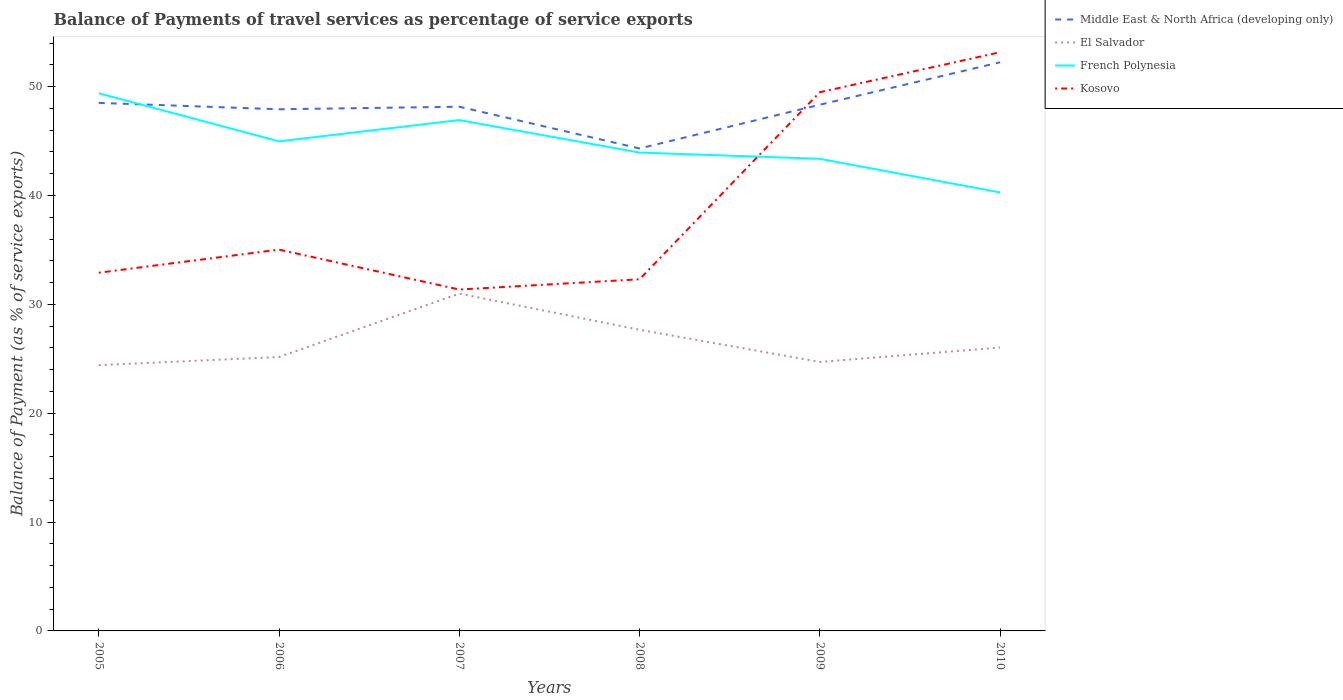Does the line corresponding to Middle East & North Africa (developing only) intersect with the line corresponding to French Polynesia?
Provide a short and direct response. Yes. Across all years, what is the maximum balance of payments of travel services in El Salvador?
Your answer should be very brief. 24.42. What is the total balance of payments of travel services in Kosovo in the graph?
Your answer should be very brief. 3.67. What is the difference between the highest and the second highest balance of payments of travel services in Middle East & North Africa (developing only)?
Ensure brevity in your answer.  7.92. What is the difference between the highest and the lowest balance of payments of travel services in French Polynesia?
Offer a very short reply. 3. How many years are there in the graph?
Give a very brief answer. 6. Where does the legend appear in the graph?
Offer a terse response. Top right. What is the title of the graph?
Make the answer very short. Balance of Payments of travel services as percentage of service exports. What is the label or title of the Y-axis?
Give a very brief answer. Balance of Payment (as % of service exports). What is the Balance of Payment (as % of service exports) of Middle East & North Africa (developing only) in 2005?
Provide a short and direct response. 48.51. What is the Balance of Payment (as % of service exports) of El Salvador in 2005?
Keep it short and to the point. 24.42. What is the Balance of Payment (as % of service exports) of French Polynesia in 2005?
Offer a terse response. 49.4. What is the Balance of Payment (as % of service exports) in Kosovo in 2005?
Provide a short and direct response. 32.91. What is the Balance of Payment (as % of service exports) in Middle East & North Africa (developing only) in 2006?
Your response must be concise. 47.93. What is the Balance of Payment (as % of service exports) of El Salvador in 2006?
Your answer should be compact. 25.17. What is the Balance of Payment (as % of service exports) of French Polynesia in 2006?
Keep it short and to the point. 44.98. What is the Balance of Payment (as % of service exports) of Kosovo in 2006?
Make the answer very short. 35.03. What is the Balance of Payment (as % of service exports) of Middle East & North Africa (developing only) in 2007?
Offer a very short reply. 48.16. What is the Balance of Payment (as % of service exports) of El Salvador in 2007?
Ensure brevity in your answer.  30.99. What is the Balance of Payment (as % of service exports) in French Polynesia in 2007?
Your answer should be compact. 46.93. What is the Balance of Payment (as % of service exports) in Kosovo in 2007?
Your answer should be very brief. 31.36. What is the Balance of Payment (as % of service exports) in Middle East & North Africa (developing only) in 2008?
Provide a succinct answer. 44.32. What is the Balance of Payment (as % of service exports) in El Salvador in 2008?
Ensure brevity in your answer.  27.67. What is the Balance of Payment (as % of service exports) of French Polynesia in 2008?
Provide a succinct answer. 43.95. What is the Balance of Payment (as % of service exports) of Kosovo in 2008?
Offer a very short reply. 32.31. What is the Balance of Payment (as % of service exports) in Middle East & North Africa (developing only) in 2009?
Provide a succinct answer. 48.34. What is the Balance of Payment (as % of service exports) in El Salvador in 2009?
Provide a short and direct response. 24.71. What is the Balance of Payment (as % of service exports) in French Polynesia in 2009?
Make the answer very short. 43.38. What is the Balance of Payment (as % of service exports) of Kosovo in 2009?
Make the answer very short. 49.49. What is the Balance of Payment (as % of service exports) of Middle East & North Africa (developing only) in 2010?
Offer a terse response. 52.24. What is the Balance of Payment (as % of service exports) in El Salvador in 2010?
Your answer should be very brief. 26.03. What is the Balance of Payment (as % of service exports) in French Polynesia in 2010?
Give a very brief answer. 40.29. What is the Balance of Payment (as % of service exports) of Kosovo in 2010?
Your response must be concise. 53.17. Across all years, what is the maximum Balance of Payment (as % of service exports) of Middle East & North Africa (developing only)?
Ensure brevity in your answer.  52.24. Across all years, what is the maximum Balance of Payment (as % of service exports) in El Salvador?
Keep it short and to the point. 30.99. Across all years, what is the maximum Balance of Payment (as % of service exports) of French Polynesia?
Offer a terse response. 49.4. Across all years, what is the maximum Balance of Payment (as % of service exports) of Kosovo?
Your response must be concise. 53.17. Across all years, what is the minimum Balance of Payment (as % of service exports) of Middle East & North Africa (developing only)?
Your answer should be compact. 44.32. Across all years, what is the minimum Balance of Payment (as % of service exports) of El Salvador?
Provide a short and direct response. 24.42. Across all years, what is the minimum Balance of Payment (as % of service exports) in French Polynesia?
Your response must be concise. 40.29. Across all years, what is the minimum Balance of Payment (as % of service exports) of Kosovo?
Keep it short and to the point. 31.36. What is the total Balance of Payment (as % of service exports) in Middle East & North Africa (developing only) in the graph?
Offer a terse response. 289.51. What is the total Balance of Payment (as % of service exports) of El Salvador in the graph?
Offer a very short reply. 158.99. What is the total Balance of Payment (as % of service exports) of French Polynesia in the graph?
Your answer should be compact. 268.93. What is the total Balance of Payment (as % of service exports) in Kosovo in the graph?
Your response must be concise. 234.27. What is the difference between the Balance of Payment (as % of service exports) of Middle East & North Africa (developing only) in 2005 and that in 2006?
Your answer should be compact. 0.59. What is the difference between the Balance of Payment (as % of service exports) in El Salvador in 2005 and that in 2006?
Offer a terse response. -0.75. What is the difference between the Balance of Payment (as % of service exports) in French Polynesia in 2005 and that in 2006?
Provide a succinct answer. 4.42. What is the difference between the Balance of Payment (as % of service exports) in Kosovo in 2005 and that in 2006?
Provide a short and direct response. -2.12. What is the difference between the Balance of Payment (as % of service exports) in Middle East & North Africa (developing only) in 2005 and that in 2007?
Keep it short and to the point. 0.35. What is the difference between the Balance of Payment (as % of service exports) in El Salvador in 2005 and that in 2007?
Offer a very short reply. -6.57. What is the difference between the Balance of Payment (as % of service exports) in French Polynesia in 2005 and that in 2007?
Provide a succinct answer. 2.47. What is the difference between the Balance of Payment (as % of service exports) in Kosovo in 2005 and that in 2007?
Provide a short and direct response. 1.55. What is the difference between the Balance of Payment (as % of service exports) of Middle East & North Africa (developing only) in 2005 and that in 2008?
Your answer should be very brief. 4.19. What is the difference between the Balance of Payment (as % of service exports) in El Salvador in 2005 and that in 2008?
Offer a very short reply. -3.25. What is the difference between the Balance of Payment (as % of service exports) in French Polynesia in 2005 and that in 2008?
Keep it short and to the point. 5.45. What is the difference between the Balance of Payment (as % of service exports) in Kosovo in 2005 and that in 2008?
Keep it short and to the point. 0.6. What is the difference between the Balance of Payment (as % of service exports) in Middle East & North Africa (developing only) in 2005 and that in 2009?
Your answer should be very brief. 0.17. What is the difference between the Balance of Payment (as % of service exports) in El Salvador in 2005 and that in 2009?
Your response must be concise. -0.29. What is the difference between the Balance of Payment (as % of service exports) of French Polynesia in 2005 and that in 2009?
Provide a short and direct response. 6.02. What is the difference between the Balance of Payment (as % of service exports) in Kosovo in 2005 and that in 2009?
Give a very brief answer. -16.58. What is the difference between the Balance of Payment (as % of service exports) in Middle East & North Africa (developing only) in 2005 and that in 2010?
Your answer should be very brief. -3.73. What is the difference between the Balance of Payment (as % of service exports) of El Salvador in 2005 and that in 2010?
Your response must be concise. -1.62. What is the difference between the Balance of Payment (as % of service exports) in French Polynesia in 2005 and that in 2010?
Ensure brevity in your answer.  9.11. What is the difference between the Balance of Payment (as % of service exports) of Kosovo in 2005 and that in 2010?
Offer a very short reply. -20.26. What is the difference between the Balance of Payment (as % of service exports) of Middle East & North Africa (developing only) in 2006 and that in 2007?
Keep it short and to the point. -0.23. What is the difference between the Balance of Payment (as % of service exports) of El Salvador in 2006 and that in 2007?
Keep it short and to the point. -5.82. What is the difference between the Balance of Payment (as % of service exports) in French Polynesia in 2006 and that in 2007?
Give a very brief answer. -1.95. What is the difference between the Balance of Payment (as % of service exports) in Kosovo in 2006 and that in 2007?
Offer a very short reply. 3.67. What is the difference between the Balance of Payment (as % of service exports) in Middle East & North Africa (developing only) in 2006 and that in 2008?
Provide a short and direct response. 3.6. What is the difference between the Balance of Payment (as % of service exports) of El Salvador in 2006 and that in 2008?
Your answer should be very brief. -2.5. What is the difference between the Balance of Payment (as % of service exports) in French Polynesia in 2006 and that in 2008?
Offer a very short reply. 1.03. What is the difference between the Balance of Payment (as % of service exports) in Kosovo in 2006 and that in 2008?
Your response must be concise. 2.72. What is the difference between the Balance of Payment (as % of service exports) of Middle East & North Africa (developing only) in 2006 and that in 2009?
Your answer should be very brief. -0.42. What is the difference between the Balance of Payment (as % of service exports) in El Salvador in 2006 and that in 2009?
Your answer should be compact. 0.45. What is the difference between the Balance of Payment (as % of service exports) of French Polynesia in 2006 and that in 2009?
Keep it short and to the point. 1.6. What is the difference between the Balance of Payment (as % of service exports) in Kosovo in 2006 and that in 2009?
Provide a succinct answer. -14.46. What is the difference between the Balance of Payment (as % of service exports) in Middle East & North Africa (developing only) in 2006 and that in 2010?
Provide a short and direct response. -4.32. What is the difference between the Balance of Payment (as % of service exports) of El Salvador in 2006 and that in 2010?
Give a very brief answer. -0.87. What is the difference between the Balance of Payment (as % of service exports) of French Polynesia in 2006 and that in 2010?
Provide a succinct answer. 4.69. What is the difference between the Balance of Payment (as % of service exports) of Kosovo in 2006 and that in 2010?
Give a very brief answer. -18.13. What is the difference between the Balance of Payment (as % of service exports) of Middle East & North Africa (developing only) in 2007 and that in 2008?
Provide a short and direct response. 3.84. What is the difference between the Balance of Payment (as % of service exports) of El Salvador in 2007 and that in 2008?
Your answer should be very brief. 3.32. What is the difference between the Balance of Payment (as % of service exports) in French Polynesia in 2007 and that in 2008?
Provide a succinct answer. 2.99. What is the difference between the Balance of Payment (as % of service exports) of Kosovo in 2007 and that in 2008?
Provide a short and direct response. -0.94. What is the difference between the Balance of Payment (as % of service exports) in Middle East & North Africa (developing only) in 2007 and that in 2009?
Offer a terse response. -0.18. What is the difference between the Balance of Payment (as % of service exports) of El Salvador in 2007 and that in 2009?
Provide a short and direct response. 6.28. What is the difference between the Balance of Payment (as % of service exports) in French Polynesia in 2007 and that in 2009?
Your answer should be compact. 3.56. What is the difference between the Balance of Payment (as % of service exports) of Kosovo in 2007 and that in 2009?
Keep it short and to the point. -18.13. What is the difference between the Balance of Payment (as % of service exports) of Middle East & North Africa (developing only) in 2007 and that in 2010?
Make the answer very short. -4.08. What is the difference between the Balance of Payment (as % of service exports) of El Salvador in 2007 and that in 2010?
Offer a terse response. 4.96. What is the difference between the Balance of Payment (as % of service exports) of French Polynesia in 2007 and that in 2010?
Offer a very short reply. 6.65. What is the difference between the Balance of Payment (as % of service exports) in Kosovo in 2007 and that in 2010?
Your response must be concise. -21.8. What is the difference between the Balance of Payment (as % of service exports) in Middle East & North Africa (developing only) in 2008 and that in 2009?
Give a very brief answer. -4.02. What is the difference between the Balance of Payment (as % of service exports) of El Salvador in 2008 and that in 2009?
Offer a terse response. 2.96. What is the difference between the Balance of Payment (as % of service exports) in French Polynesia in 2008 and that in 2009?
Your response must be concise. 0.57. What is the difference between the Balance of Payment (as % of service exports) in Kosovo in 2008 and that in 2009?
Keep it short and to the point. -17.18. What is the difference between the Balance of Payment (as % of service exports) in Middle East & North Africa (developing only) in 2008 and that in 2010?
Offer a terse response. -7.92. What is the difference between the Balance of Payment (as % of service exports) of El Salvador in 2008 and that in 2010?
Ensure brevity in your answer.  1.63. What is the difference between the Balance of Payment (as % of service exports) in French Polynesia in 2008 and that in 2010?
Offer a very short reply. 3.66. What is the difference between the Balance of Payment (as % of service exports) of Kosovo in 2008 and that in 2010?
Make the answer very short. -20.86. What is the difference between the Balance of Payment (as % of service exports) of Middle East & North Africa (developing only) in 2009 and that in 2010?
Ensure brevity in your answer.  -3.9. What is the difference between the Balance of Payment (as % of service exports) in El Salvador in 2009 and that in 2010?
Offer a very short reply. -1.32. What is the difference between the Balance of Payment (as % of service exports) of French Polynesia in 2009 and that in 2010?
Keep it short and to the point. 3.09. What is the difference between the Balance of Payment (as % of service exports) of Kosovo in 2009 and that in 2010?
Your response must be concise. -3.67. What is the difference between the Balance of Payment (as % of service exports) in Middle East & North Africa (developing only) in 2005 and the Balance of Payment (as % of service exports) in El Salvador in 2006?
Provide a succinct answer. 23.35. What is the difference between the Balance of Payment (as % of service exports) of Middle East & North Africa (developing only) in 2005 and the Balance of Payment (as % of service exports) of French Polynesia in 2006?
Your response must be concise. 3.53. What is the difference between the Balance of Payment (as % of service exports) in Middle East & North Africa (developing only) in 2005 and the Balance of Payment (as % of service exports) in Kosovo in 2006?
Your answer should be very brief. 13.48. What is the difference between the Balance of Payment (as % of service exports) in El Salvador in 2005 and the Balance of Payment (as % of service exports) in French Polynesia in 2006?
Offer a terse response. -20.56. What is the difference between the Balance of Payment (as % of service exports) of El Salvador in 2005 and the Balance of Payment (as % of service exports) of Kosovo in 2006?
Your answer should be very brief. -10.61. What is the difference between the Balance of Payment (as % of service exports) in French Polynesia in 2005 and the Balance of Payment (as % of service exports) in Kosovo in 2006?
Your response must be concise. 14.37. What is the difference between the Balance of Payment (as % of service exports) in Middle East & North Africa (developing only) in 2005 and the Balance of Payment (as % of service exports) in El Salvador in 2007?
Offer a terse response. 17.52. What is the difference between the Balance of Payment (as % of service exports) of Middle East & North Africa (developing only) in 2005 and the Balance of Payment (as % of service exports) of French Polynesia in 2007?
Offer a terse response. 1.58. What is the difference between the Balance of Payment (as % of service exports) in Middle East & North Africa (developing only) in 2005 and the Balance of Payment (as % of service exports) in Kosovo in 2007?
Your answer should be very brief. 17.15. What is the difference between the Balance of Payment (as % of service exports) of El Salvador in 2005 and the Balance of Payment (as % of service exports) of French Polynesia in 2007?
Your answer should be very brief. -22.52. What is the difference between the Balance of Payment (as % of service exports) in El Salvador in 2005 and the Balance of Payment (as % of service exports) in Kosovo in 2007?
Your response must be concise. -6.95. What is the difference between the Balance of Payment (as % of service exports) in French Polynesia in 2005 and the Balance of Payment (as % of service exports) in Kosovo in 2007?
Your response must be concise. 18.04. What is the difference between the Balance of Payment (as % of service exports) in Middle East & North Africa (developing only) in 2005 and the Balance of Payment (as % of service exports) in El Salvador in 2008?
Provide a short and direct response. 20.84. What is the difference between the Balance of Payment (as % of service exports) in Middle East & North Africa (developing only) in 2005 and the Balance of Payment (as % of service exports) in French Polynesia in 2008?
Ensure brevity in your answer.  4.56. What is the difference between the Balance of Payment (as % of service exports) in Middle East & North Africa (developing only) in 2005 and the Balance of Payment (as % of service exports) in Kosovo in 2008?
Ensure brevity in your answer.  16.2. What is the difference between the Balance of Payment (as % of service exports) of El Salvador in 2005 and the Balance of Payment (as % of service exports) of French Polynesia in 2008?
Offer a very short reply. -19.53. What is the difference between the Balance of Payment (as % of service exports) in El Salvador in 2005 and the Balance of Payment (as % of service exports) in Kosovo in 2008?
Keep it short and to the point. -7.89. What is the difference between the Balance of Payment (as % of service exports) of French Polynesia in 2005 and the Balance of Payment (as % of service exports) of Kosovo in 2008?
Provide a short and direct response. 17.09. What is the difference between the Balance of Payment (as % of service exports) of Middle East & North Africa (developing only) in 2005 and the Balance of Payment (as % of service exports) of El Salvador in 2009?
Provide a succinct answer. 23.8. What is the difference between the Balance of Payment (as % of service exports) of Middle East & North Africa (developing only) in 2005 and the Balance of Payment (as % of service exports) of French Polynesia in 2009?
Your answer should be very brief. 5.13. What is the difference between the Balance of Payment (as % of service exports) of Middle East & North Africa (developing only) in 2005 and the Balance of Payment (as % of service exports) of Kosovo in 2009?
Provide a succinct answer. -0.98. What is the difference between the Balance of Payment (as % of service exports) of El Salvador in 2005 and the Balance of Payment (as % of service exports) of French Polynesia in 2009?
Keep it short and to the point. -18.96. What is the difference between the Balance of Payment (as % of service exports) in El Salvador in 2005 and the Balance of Payment (as % of service exports) in Kosovo in 2009?
Your response must be concise. -25.07. What is the difference between the Balance of Payment (as % of service exports) of French Polynesia in 2005 and the Balance of Payment (as % of service exports) of Kosovo in 2009?
Give a very brief answer. -0.09. What is the difference between the Balance of Payment (as % of service exports) in Middle East & North Africa (developing only) in 2005 and the Balance of Payment (as % of service exports) in El Salvador in 2010?
Offer a very short reply. 22.48. What is the difference between the Balance of Payment (as % of service exports) of Middle East & North Africa (developing only) in 2005 and the Balance of Payment (as % of service exports) of French Polynesia in 2010?
Give a very brief answer. 8.22. What is the difference between the Balance of Payment (as % of service exports) in Middle East & North Africa (developing only) in 2005 and the Balance of Payment (as % of service exports) in Kosovo in 2010?
Provide a succinct answer. -4.66. What is the difference between the Balance of Payment (as % of service exports) of El Salvador in 2005 and the Balance of Payment (as % of service exports) of French Polynesia in 2010?
Provide a succinct answer. -15.87. What is the difference between the Balance of Payment (as % of service exports) in El Salvador in 2005 and the Balance of Payment (as % of service exports) in Kosovo in 2010?
Ensure brevity in your answer.  -28.75. What is the difference between the Balance of Payment (as % of service exports) in French Polynesia in 2005 and the Balance of Payment (as % of service exports) in Kosovo in 2010?
Offer a terse response. -3.77. What is the difference between the Balance of Payment (as % of service exports) in Middle East & North Africa (developing only) in 2006 and the Balance of Payment (as % of service exports) in El Salvador in 2007?
Offer a terse response. 16.94. What is the difference between the Balance of Payment (as % of service exports) of Middle East & North Africa (developing only) in 2006 and the Balance of Payment (as % of service exports) of Kosovo in 2007?
Provide a short and direct response. 16.56. What is the difference between the Balance of Payment (as % of service exports) in El Salvador in 2006 and the Balance of Payment (as % of service exports) in French Polynesia in 2007?
Make the answer very short. -21.77. What is the difference between the Balance of Payment (as % of service exports) of El Salvador in 2006 and the Balance of Payment (as % of service exports) of Kosovo in 2007?
Provide a succinct answer. -6.2. What is the difference between the Balance of Payment (as % of service exports) of French Polynesia in 2006 and the Balance of Payment (as % of service exports) of Kosovo in 2007?
Keep it short and to the point. 13.62. What is the difference between the Balance of Payment (as % of service exports) of Middle East & North Africa (developing only) in 2006 and the Balance of Payment (as % of service exports) of El Salvador in 2008?
Offer a very short reply. 20.26. What is the difference between the Balance of Payment (as % of service exports) of Middle East & North Africa (developing only) in 2006 and the Balance of Payment (as % of service exports) of French Polynesia in 2008?
Your answer should be very brief. 3.98. What is the difference between the Balance of Payment (as % of service exports) in Middle East & North Africa (developing only) in 2006 and the Balance of Payment (as % of service exports) in Kosovo in 2008?
Give a very brief answer. 15.62. What is the difference between the Balance of Payment (as % of service exports) in El Salvador in 2006 and the Balance of Payment (as % of service exports) in French Polynesia in 2008?
Offer a terse response. -18.78. What is the difference between the Balance of Payment (as % of service exports) in El Salvador in 2006 and the Balance of Payment (as % of service exports) in Kosovo in 2008?
Offer a terse response. -7.14. What is the difference between the Balance of Payment (as % of service exports) of French Polynesia in 2006 and the Balance of Payment (as % of service exports) of Kosovo in 2008?
Keep it short and to the point. 12.67. What is the difference between the Balance of Payment (as % of service exports) of Middle East & North Africa (developing only) in 2006 and the Balance of Payment (as % of service exports) of El Salvador in 2009?
Provide a succinct answer. 23.21. What is the difference between the Balance of Payment (as % of service exports) in Middle East & North Africa (developing only) in 2006 and the Balance of Payment (as % of service exports) in French Polynesia in 2009?
Provide a succinct answer. 4.55. What is the difference between the Balance of Payment (as % of service exports) in Middle East & North Africa (developing only) in 2006 and the Balance of Payment (as % of service exports) in Kosovo in 2009?
Provide a succinct answer. -1.57. What is the difference between the Balance of Payment (as % of service exports) in El Salvador in 2006 and the Balance of Payment (as % of service exports) in French Polynesia in 2009?
Offer a terse response. -18.21. What is the difference between the Balance of Payment (as % of service exports) in El Salvador in 2006 and the Balance of Payment (as % of service exports) in Kosovo in 2009?
Keep it short and to the point. -24.33. What is the difference between the Balance of Payment (as % of service exports) in French Polynesia in 2006 and the Balance of Payment (as % of service exports) in Kosovo in 2009?
Provide a succinct answer. -4.51. What is the difference between the Balance of Payment (as % of service exports) of Middle East & North Africa (developing only) in 2006 and the Balance of Payment (as % of service exports) of El Salvador in 2010?
Your answer should be very brief. 21.89. What is the difference between the Balance of Payment (as % of service exports) of Middle East & North Africa (developing only) in 2006 and the Balance of Payment (as % of service exports) of French Polynesia in 2010?
Give a very brief answer. 7.64. What is the difference between the Balance of Payment (as % of service exports) in Middle East & North Africa (developing only) in 2006 and the Balance of Payment (as % of service exports) in Kosovo in 2010?
Provide a short and direct response. -5.24. What is the difference between the Balance of Payment (as % of service exports) of El Salvador in 2006 and the Balance of Payment (as % of service exports) of French Polynesia in 2010?
Your answer should be very brief. -15.12. What is the difference between the Balance of Payment (as % of service exports) of El Salvador in 2006 and the Balance of Payment (as % of service exports) of Kosovo in 2010?
Your answer should be very brief. -28. What is the difference between the Balance of Payment (as % of service exports) of French Polynesia in 2006 and the Balance of Payment (as % of service exports) of Kosovo in 2010?
Your response must be concise. -8.19. What is the difference between the Balance of Payment (as % of service exports) of Middle East & North Africa (developing only) in 2007 and the Balance of Payment (as % of service exports) of El Salvador in 2008?
Give a very brief answer. 20.49. What is the difference between the Balance of Payment (as % of service exports) of Middle East & North Africa (developing only) in 2007 and the Balance of Payment (as % of service exports) of French Polynesia in 2008?
Provide a succinct answer. 4.21. What is the difference between the Balance of Payment (as % of service exports) in Middle East & North Africa (developing only) in 2007 and the Balance of Payment (as % of service exports) in Kosovo in 2008?
Make the answer very short. 15.85. What is the difference between the Balance of Payment (as % of service exports) of El Salvador in 2007 and the Balance of Payment (as % of service exports) of French Polynesia in 2008?
Give a very brief answer. -12.96. What is the difference between the Balance of Payment (as % of service exports) in El Salvador in 2007 and the Balance of Payment (as % of service exports) in Kosovo in 2008?
Your response must be concise. -1.32. What is the difference between the Balance of Payment (as % of service exports) of French Polynesia in 2007 and the Balance of Payment (as % of service exports) of Kosovo in 2008?
Provide a short and direct response. 14.63. What is the difference between the Balance of Payment (as % of service exports) of Middle East & North Africa (developing only) in 2007 and the Balance of Payment (as % of service exports) of El Salvador in 2009?
Your answer should be compact. 23.45. What is the difference between the Balance of Payment (as % of service exports) of Middle East & North Africa (developing only) in 2007 and the Balance of Payment (as % of service exports) of French Polynesia in 2009?
Give a very brief answer. 4.78. What is the difference between the Balance of Payment (as % of service exports) of Middle East & North Africa (developing only) in 2007 and the Balance of Payment (as % of service exports) of Kosovo in 2009?
Offer a terse response. -1.33. What is the difference between the Balance of Payment (as % of service exports) of El Salvador in 2007 and the Balance of Payment (as % of service exports) of French Polynesia in 2009?
Ensure brevity in your answer.  -12.39. What is the difference between the Balance of Payment (as % of service exports) of El Salvador in 2007 and the Balance of Payment (as % of service exports) of Kosovo in 2009?
Your response must be concise. -18.5. What is the difference between the Balance of Payment (as % of service exports) of French Polynesia in 2007 and the Balance of Payment (as % of service exports) of Kosovo in 2009?
Make the answer very short. -2.56. What is the difference between the Balance of Payment (as % of service exports) of Middle East & North Africa (developing only) in 2007 and the Balance of Payment (as % of service exports) of El Salvador in 2010?
Provide a short and direct response. 22.13. What is the difference between the Balance of Payment (as % of service exports) of Middle East & North Africa (developing only) in 2007 and the Balance of Payment (as % of service exports) of French Polynesia in 2010?
Provide a succinct answer. 7.87. What is the difference between the Balance of Payment (as % of service exports) of Middle East & North Africa (developing only) in 2007 and the Balance of Payment (as % of service exports) of Kosovo in 2010?
Offer a terse response. -5.01. What is the difference between the Balance of Payment (as % of service exports) in El Salvador in 2007 and the Balance of Payment (as % of service exports) in French Polynesia in 2010?
Offer a terse response. -9.3. What is the difference between the Balance of Payment (as % of service exports) of El Salvador in 2007 and the Balance of Payment (as % of service exports) of Kosovo in 2010?
Your answer should be compact. -22.18. What is the difference between the Balance of Payment (as % of service exports) of French Polynesia in 2007 and the Balance of Payment (as % of service exports) of Kosovo in 2010?
Ensure brevity in your answer.  -6.23. What is the difference between the Balance of Payment (as % of service exports) in Middle East & North Africa (developing only) in 2008 and the Balance of Payment (as % of service exports) in El Salvador in 2009?
Give a very brief answer. 19.61. What is the difference between the Balance of Payment (as % of service exports) of Middle East & North Africa (developing only) in 2008 and the Balance of Payment (as % of service exports) of French Polynesia in 2009?
Keep it short and to the point. 0.95. What is the difference between the Balance of Payment (as % of service exports) of Middle East & North Africa (developing only) in 2008 and the Balance of Payment (as % of service exports) of Kosovo in 2009?
Provide a short and direct response. -5.17. What is the difference between the Balance of Payment (as % of service exports) of El Salvador in 2008 and the Balance of Payment (as % of service exports) of French Polynesia in 2009?
Ensure brevity in your answer.  -15.71. What is the difference between the Balance of Payment (as % of service exports) in El Salvador in 2008 and the Balance of Payment (as % of service exports) in Kosovo in 2009?
Your response must be concise. -21.82. What is the difference between the Balance of Payment (as % of service exports) in French Polynesia in 2008 and the Balance of Payment (as % of service exports) in Kosovo in 2009?
Your response must be concise. -5.54. What is the difference between the Balance of Payment (as % of service exports) in Middle East & North Africa (developing only) in 2008 and the Balance of Payment (as % of service exports) in El Salvador in 2010?
Give a very brief answer. 18.29. What is the difference between the Balance of Payment (as % of service exports) in Middle East & North Africa (developing only) in 2008 and the Balance of Payment (as % of service exports) in French Polynesia in 2010?
Offer a terse response. 4.04. What is the difference between the Balance of Payment (as % of service exports) of Middle East & North Africa (developing only) in 2008 and the Balance of Payment (as % of service exports) of Kosovo in 2010?
Offer a terse response. -8.84. What is the difference between the Balance of Payment (as % of service exports) in El Salvador in 2008 and the Balance of Payment (as % of service exports) in French Polynesia in 2010?
Your response must be concise. -12.62. What is the difference between the Balance of Payment (as % of service exports) of El Salvador in 2008 and the Balance of Payment (as % of service exports) of Kosovo in 2010?
Offer a very short reply. -25.5. What is the difference between the Balance of Payment (as % of service exports) of French Polynesia in 2008 and the Balance of Payment (as % of service exports) of Kosovo in 2010?
Offer a very short reply. -9.22. What is the difference between the Balance of Payment (as % of service exports) in Middle East & North Africa (developing only) in 2009 and the Balance of Payment (as % of service exports) in El Salvador in 2010?
Offer a very short reply. 22.31. What is the difference between the Balance of Payment (as % of service exports) of Middle East & North Africa (developing only) in 2009 and the Balance of Payment (as % of service exports) of French Polynesia in 2010?
Your answer should be compact. 8.05. What is the difference between the Balance of Payment (as % of service exports) of Middle East & North Africa (developing only) in 2009 and the Balance of Payment (as % of service exports) of Kosovo in 2010?
Keep it short and to the point. -4.82. What is the difference between the Balance of Payment (as % of service exports) in El Salvador in 2009 and the Balance of Payment (as % of service exports) in French Polynesia in 2010?
Offer a very short reply. -15.58. What is the difference between the Balance of Payment (as % of service exports) of El Salvador in 2009 and the Balance of Payment (as % of service exports) of Kosovo in 2010?
Keep it short and to the point. -28.46. What is the difference between the Balance of Payment (as % of service exports) in French Polynesia in 2009 and the Balance of Payment (as % of service exports) in Kosovo in 2010?
Offer a very short reply. -9.79. What is the average Balance of Payment (as % of service exports) of Middle East & North Africa (developing only) per year?
Offer a terse response. 48.25. What is the average Balance of Payment (as % of service exports) in El Salvador per year?
Offer a terse response. 26.5. What is the average Balance of Payment (as % of service exports) of French Polynesia per year?
Keep it short and to the point. 44.82. What is the average Balance of Payment (as % of service exports) of Kosovo per year?
Ensure brevity in your answer.  39.05. In the year 2005, what is the difference between the Balance of Payment (as % of service exports) of Middle East & North Africa (developing only) and Balance of Payment (as % of service exports) of El Salvador?
Your answer should be compact. 24.09. In the year 2005, what is the difference between the Balance of Payment (as % of service exports) of Middle East & North Africa (developing only) and Balance of Payment (as % of service exports) of French Polynesia?
Your answer should be very brief. -0.89. In the year 2005, what is the difference between the Balance of Payment (as % of service exports) of Middle East & North Africa (developing only) and Balance of Payment (as % of service exports) of Kosovo?
Offer a terse response. 15.6. In the year 2005, what is the difference between the Balance of Payment (as % of service exports) of El Salvador and Balance of Payment (as % of service exports) of French Polynesia?
Offer a terse response. -24.98. In the year 2005, what is the difference between the Balance of Payment (as % of service exports) of El Salvador and Balance of Payment (as % of service exports) of Kosovo?
Give a very brief answer. -8.49. In the year 2005, what is the difference between the Balance of Payment (as % of service exports) in French Polynesia and Balance of Payment (as % of service exports) in Kosovo?
Give a very brief answer. 16.49. In the year 2006, what is the difference between the Balance of Payment (as % of service exports) in Middle East & North Africa (developing only) and Balance of Payment (as % of service exports) in El Salvador?
Your response must be concise. 22.76. In the year 2006, what is the difference between the Balance of Payment (as % of service exports) in Middle East & North Africa (developing only) and Balance of Payment (as % of service exports) in French Polynesia?
Keep it short and to the point. 2.95. In the year 2006, what is the difference between the Balance of Payment (as % of service exports) of Middle East & North Africa (developing only) and Balance of Payment (as % of service exports) of Kosovo?
Provide a short and direct response. 12.89. In the year 2006, what is the difference between the Balance of Payment (as % of service exports) in El Salvador and Balance of Payment (as % of service exports) in French Polynesia?
Give a very brief answer. -19.81. In the year 2006, what is the difference between the Balance of Payment (as % of service exports) in El Salvador and Balance of Payment (as % of service exports) in Kosovo?
Your response must be concise. -9.87. In the year 2006, what is the difference between the Balance of Payment (as % of service exports) in French Polynesia and Balance of Payment (as % of service exports) in Kosovo?
Your response must be concise. 9.95. In the year 2007, what is the difference between the Balance of Payment (as % of service exports) in Middle East & North Africa (developing only) and Balance of Payment (as % of service exports) in El Salvador?
Provide a short and direct response. 17.17. In the year 2007, what is the difference between the Balance of Payment (as % of service exports) of Middle East & North Africa (developing only) and Balance of Payment (as % of service exports) of French Polynesia?
Offer a terse response. 1.23. In the year 2007, what is the difference between the Balance of Payment (as % of service exports) in Middle East & North Africa (developing only) and Balance of Payment (as % of service exports) in Kosovo?
Make the answer very short. 16.8. In the year 2007, what is the difference between the Balance of Payment (as % of service exports) of El Salvador and Balance of Payment (as % of service exports) of French Polynesia?
Offer a terse response. -15.94. In the year 2007, what is the difference between the Balance of Payment (as % of service exports) in El Salvador and Balance of Payment (as % of service exports) in Kosovo?
Your answer should be compact. -0.37. In the year 2007, what is the difference between the Balance of Payment (as % of service exports) in French Polynesia and Balance of Payment (as % of service exports) in Kosovo?
Make the answer very short. 15.57. In the year 2008, what is the difference between the Balance of Payment (as % of service exports) in Middle East & North Africa (developing only) and Balance of Payment (as % of service exports) in El Salvador?
Make the answer very short. 16.66. In the year 2008, what is the difference between the Balance of Payment (as % of service exports) in Middle East & North Africa (developing only) and Balance of Payment (as % of service exports) in French Polynesia?
Provide a short and direct response. 0.38. In the year 2008, what is the difference between the Balance of Payment (as % of service exports) of Middle East & North Africa (developing only) and Balance of Payment (as % of service exports) of Kosovo?
Your answer should be very brief. 12.02. In the year 2008, what is the difference between the Balance of Payment (as % of service exports) in El Salvador and Balance of Payment (as % of service exports) in French Polynesia?
Your response must be concise. -16.28. In the year 2008, what is the difference between the Balance of Payment (as % of service exports) of El Salvador and Balance of Payment (as % of service exports) of Kosovo?
Offer a terse response. -4.64. In the year 2008, what is the difference between the Balance of Payment (as % of service exports) of French Polynesia and Balance of Payment (as % of service exports) of Kosovo?
Provide a succinct answer. 11.64. In the year 2009, what is the difference between the Balance of Payment (as % of service exports) of Middle East & North Africa (developing only) and Balance of Payment (as % of service exports) of El Salvador?
Ensure brevity in your answer.  23.63. In the year 2009, what is the difference between the Balance of Payment (as % of service exports) of Middle East & North Africa (developing only) and Balance of Payment (as % of service exports) of French Polynesia?
Offer a terse response. 4.97. In the year 2009, what is the difference between the Balance of Payment (as % of service exports) of Middle East & North Africa (developing only) and Balance of Payment (as % of service exports) of Kosovo?
Offer a terse response. -1.15. In the year 2009, what is the difference between the Balance of Payment (as % of service exports) in El Salvador and Balance of Payment (as % of service exports) in French Polynesia?
Your answer should be very brief. -18.67. In the year 2009, what is the difference between the Balance of Payment (as % of service exports) in El Salvador and Balance of Payment (as % of service exports) in Kosovo?
Ensure brevity in your answer.  -24.78. In the year 2009, what is the difference between the Balance of Payment (as % of service exports) of French Polynesia and Balance of Payment (as % of service exports) of Kosovo?
Offer a very short reply. -6.12. In the year 2010, what is the difference between the Balance of Payment (as % of service exports) in Middle East & North Africa (developing only) and Balance of Payment (as % of service exports) in El Salvador?
Your response must be concise. 26.21. In the year 2010, what is the difference between the Balance of Payment (as % of service exports) in Middle East & North Africa (developing only) and Balance of Payment (as % of service exports) in French Polynesia?
Your answer should be very brief. 11.95. In the year 2010, what is the difference between the Balance of Payment (as % of service exports) in Middle East & North Africa (developing only) and Balance of Payment (as % of service exports) in Kosovo?
Provide a succinct answer. -0.93. In the year 2010, what is the difference between the Balance of Payment (as % of service exports) of El Salvador and Balance of Payment (as % of service exports) of French Polynesia?
Your response must be concise. -14.25. In the year 2010, what is the difference between the Balance of Payment (as % of service exports) in El Salvador and Balance of Payment (as % of service exports) in Kosovo?
Provide a succinct answer. -27.13. In the year 2010, what is the difference between the Balance of Payment (as % of service exports) in French Polynesia and Balance of Payment (as % of service exports) in Kosovo?
Your response must be concise. -12.88. What is the ratio of the Balance of Payment (as % of service exports) in Middle East & North Africa (developing only) in 2005 to that in 2006?
Keep it short and to the point. 1.01. What is the ratio of the Balance of Payment (as % of service exports) of El Salvador in 2005 to that in 2006?
Provide a short and direct response. 0.97. What is the ratio of the Balance of Payment (as % of service exports) of French Polynesia in 2005 to that in 2006?
Offer a terse response. 1.1. What is the ratio of the Balance of Payment (as % of service exports) of Kosovo in 2005 to that in 2006?
Your response must be concise. 0.94. What is the ratio of the Balance of Payment (as % of service exports) of Middle East & North Africa (developing only) in 2005 to that in 2007?
Offer a very short reply. 1.01. What is the ratio of the Balance of Payment (as % of service exports) in El Salvador in 2005 to that in 2007?
Your answer should be very brief. 0.79. What is the ratio of the Balance of Payment (as % of service exports) of French Polynesia in 2005 to that in 2007?
Offer a very short reply. 1.05. What is the ratio of the Balance of Payment (as % of service exports) of Kosovo in 2005 to that in 2007?
Offer a terse response. 1.05. What is the ratio of the Balance of Payment (as % of service exports) of Middle East & North Africa (developing only) in 2005 to that in 2008?
Ensure brevity in your answer.  1.09. What is the ratio of the Balance of Payment (as % of service exports) in El Salvador in 2005 to that in 2008?
Ensure brevity in your answer.  0.88. What is the ratio of the Balance of Payment (as % of service exports) of French Polynesia in 2005 to that in 2008?
Your answer should be compact. 1.12. What is the ratio of the Balance of Payment (as % of service exports) of Kosovo in 2005 to that in 2008?
Your answer should be compact. 1.02. What is the ratio of the Balance of Payment (as % of service exports) in Middle East & North Africa (developing only) in 2005 to that in 2009?
Make the answer very short. 1. What is the ratio of the Balance of Payment (as % of service exports) of French Polynesia in 2005 to that in 2009?
Your answer should be very brief. 1.14. What is the ratio of the Balance of Payment (as % of service exports) in Kosovo in 2005 to that in 2009?
Your answer should be very brief. 0.67. What is the ratio of the Balance of Payment (as % of service exports) of El Salvador in 2005 to that in 2010?
Give a very brief answer. 0.94. What is the ratio of the Balance of Payment (as % of service exports) in French Polynesia in 2005 to that in 2010?
Provide a short and direct response. 1.23. What is the ratio of the Balance of Payment (as % of service exports) in Kosovo in 2005 to that in 2010?
Your answer should be compact. 0.62. What is the ratio of the Balance of Payment (as % of service exports) of Middle East & North Africa (developing only) in 2006 to that in 2007?
Ensure brevity in your answer.  1. What is the ratio of the Balance of Payment (as % of service exports) in El Salvador in 2006 to that in 2007?
Offer a very short reply. 0.81. What is the ratio of the Balance of Payment (as % of service exports) of French Polynesia in 2006 to that in 2007?
Make the answer very short. 0.96. What is the ratio of the Balance of Payment (as % of service exports) in Kosovo in 2006 to that in 2007?
Give a very brief answer. 1.12. What is the ratio of the Balance of Payment (as % of service exports) in Middle East & North Africa (developing only) in 2006 to that in 2008?
Make the answer very short. 1.08. What is the ratio of the Balance of Payment (as % of service exports) in El Salvador in 2006 to that in 2008?
Make the answer very short. 0.91. What is the ratio of the Balance of Payment (as % of service exports) in French Polynesia in 2006 to that in 2008?
Your answer should be very brief. 1.02. What is the ratio of the Balance of Payment (as % of service exports) of Kosovo in 2006 to that in 2008?
Keep it short and to the point. 1.08. What is the ratio of the Balance of Payment (as % of service exports) of El Salvador in 2006 to that in 2009?
Your answer should be compact. 1.02. What is the ratio of the Balance of Payment (as % of service exports) of French Polynesia in 2006 to that in 2009?
Offer a very short reply. 1.04. What is the ratio of the Balance of Payment (as % of service exports) of Kosovo in 2006 to that in 2009?
Your response must be concise. 0.71. What is the ratio of the Balance of Payment (as % of service exports) in Middle East & North Africa (developing only) in 2006 to that in 2010?
Give a very brief answer. 0.92. What is the ratio of the Balance of Payment (as % of service exports) of El Salvador in 2006 to that in 2010?
Keep it short and to the point. 0.97. What is the ratio of the Balance of Payment (as % of service exports) in French Polynesia in 2006 to that in 2010?
Make the answer very short. 1.12. What is the ratio of the Balance of Payment (as % of service exports) of Kosovo in 2006 to that in 2010?
Offer a terse response. 0.66. What is the ratio of the Balance of Payment (as % of service exports) of Middle East & North Africa (developing only) in 2007 to that in 2008?
Give a very brief answer. 1.09. What is the ratio of the Balance of Payment (as % of service exports) of El Salvador in 2007 to that in 2008?
Your answer should be compact. 1.12. What is the ratio of the Balance of Payment (as % of service exports) of French Polynesia in 2007 to that in 2008?
Offer a very short reply. 1.07. What is the ratio of the Balance of Payment (as % of service exports) in Kosovo in 2007 to that in 2008?
Make the answer very short. 0.97. What is the ratio of the Balance of Payment (as % of service exports) of Middle East & North Africa (developing only) in 2007 to that in 2009?
Ensure brevity in your answer.  1. What is the ratio of the Balance of Payment (as % of service exports) of El Salvador in 2007 to that in 2009?
Ensure brevity in your answer.  1.25. What is the ratio of the Balance of Payment (as % of service exports) of French Polynesia in 2007 to that in 2009?
Ensure brevity in your answer.  1.08. What is the ratio of the Balance of Payment (as % of service exports) of Kosovo in 2007 to that in 2009?
Provide a short and direct response. 0.63. What is the ratio of the Balance of Payment (as % of service exports) in Middle East & North Africa (developing only) in 2007 to that in 2010?
Offer a terse response. 0.92. What is the ratio of the Balance of Payment (as % of service exports) in El Salvador in 2007 to that in 2010?
Make the answer very short. 1.19. What is the ratio of the Balance of Payment (as % of service exports) of French Polynesia in 2007 to that in 2010?
Provide a succinct answer. 1.17. What is the ratio of the Balance of Payment (as % of service exports) in Kosovo in 2007 to that in 2010?
Provide a succinct answer. 0.59. What is the ratio of the Balance of Payment (as % of service exports) of Middle East & North Africa (developing only) in 2008 to that in 2009?
Provide a short and direct response. 0.92. What is the ratio of the Balance of Payment (as % of service exports) in El Salvador in 2008 to that in 2009?
Your response must be concise. 1.12. What is the ratio of the Balance of Payment (as % of service exports) of French Polynesia in 2008 to that in 2009?
Your answer should be compact. 1.01. What is the ratio of the Balance of Payment (as % of service exports) in Kosovo in 2008 to that in 2009?
Give a very brief answer. 0.65. What is the ratio of the Balance of Payment (as % of service exports) in Middle East & North Africa (developing only) in 2008 to that in 2010?
Offer a very short reply. 0.85. What is the ratio of the Balance of Payment (as % of service exports) of El Salvador in 2008 to that in 2010?
Your response must be concise. 1.06. What is the ratio of the Balance of Payment (as % of service exports) in French Polynesia in 2008 to that in 2010?
Ensure brevity in your answer.  1.09. What is the ratio of the Balance of Payment (as % of service exports) of Kosovo in 2008 to that in 2010?
Make the answer very short. 0.61. What is the ratio of the Balance of Payment (as % of service exports) of Middle East & North Africa (developing only) in 2009 to that in 2010?
Keep it short and to the point. 0.93. What is the ratio of the Balance of Payment (as % of service exports) of El Salvador in 2009 to that in 2010?
Give a very brief answer. 0.95. What is the ratio of the Balance of Payment (as % of service exports) in French Polynesia in 2009 to that in 2010?
Make the answer very short. 1.08. What is the ratio of the Balance of Payment (as % of service exports) in Kosovo in 2009 to that in 2010?
Offer a terse response. 0.93. What is the difference between the highest and the second highest Balance of Payment (as % of service exports) of Middle East & North Africa (developing only)?
Your answer should be compact. 3.73. What is the difference between the highest and the second highest Balance of Payment (as % of service exports) in El Salvador?
Offer a very short reply. 3.32. What is the difference between the highest and the second highest Balance of Payment (as % of service exports) of French Polynesia?
Provide a succinct answer. 2.47. What is the difference between the highest and the second highest Balance of Payment (as % of service exports) in Kosovo?
Provide a succinct answer. 3.67. What is the difference between the highest and the lowest Balance of Payment (as % of service exports) of Middle East & North Africa (developing only)?
Your answer should be compact. 7.92. What is the difference between the highest and the lowest Balance of Payment (as % of service exports) in El Salvador?
Your response must be concise. 6.57. What is the difference between the highest and the lowest Balance of Payment (as % of service exports) of French Polynesia?
Provide a succinct answer. 9.11. What is the difference between the highest and the lowest Balance of Payment (as % of service exports) in Kosovo?
Provide a short and direct response. 21.8. 